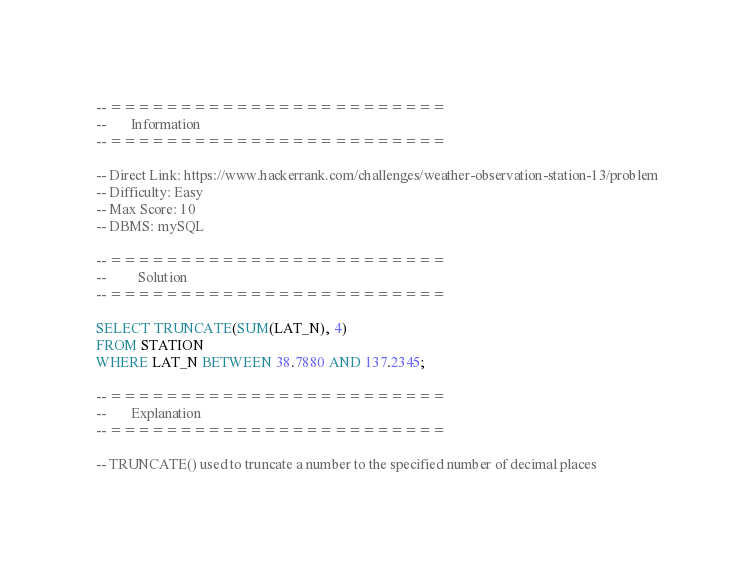<code> <loc_0><loc_0><loc_500><loc_500><_SQL_>-- ========================
--       Information
-- ========================

-- Direct Link: https://www.hackerrank.com/challenges/weather-observation-station-13/problem
-- Difficulty: Easy
-- Max Score: 10
-- DBMS: mySQL

-- ========================
--         Solution
-- ========================

SELECT TRUNCATE(SUM(LAT_N), 4)
FROM STATION
WHERE LAT_N BETWEEN 38.7880 AND 137.2345;

-- ========================
--       Explanation
-- ========================

-- TRUNCATE() used to truncate a number to the specified number of decimal places
</code> 